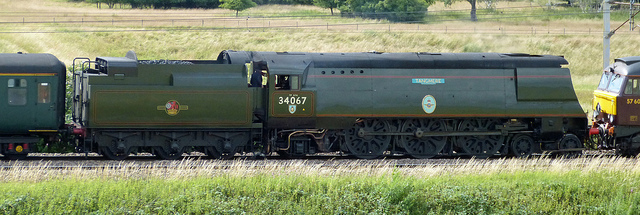Please transcribe the text in this image. 34067 